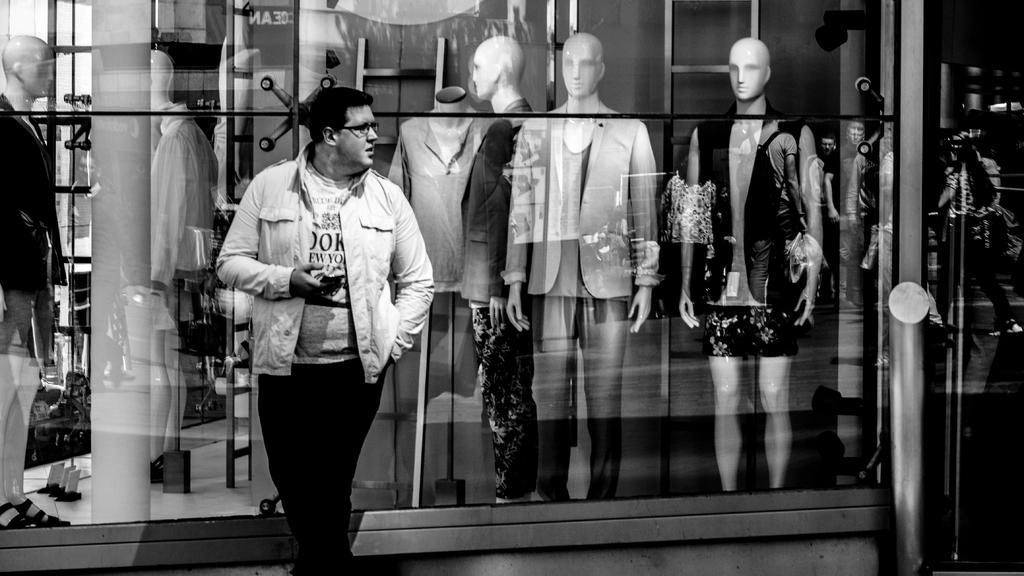Describe this image in one or two sentences. In this black and white image we can see there is a man standing and looking at something and also there are some statue of men. 